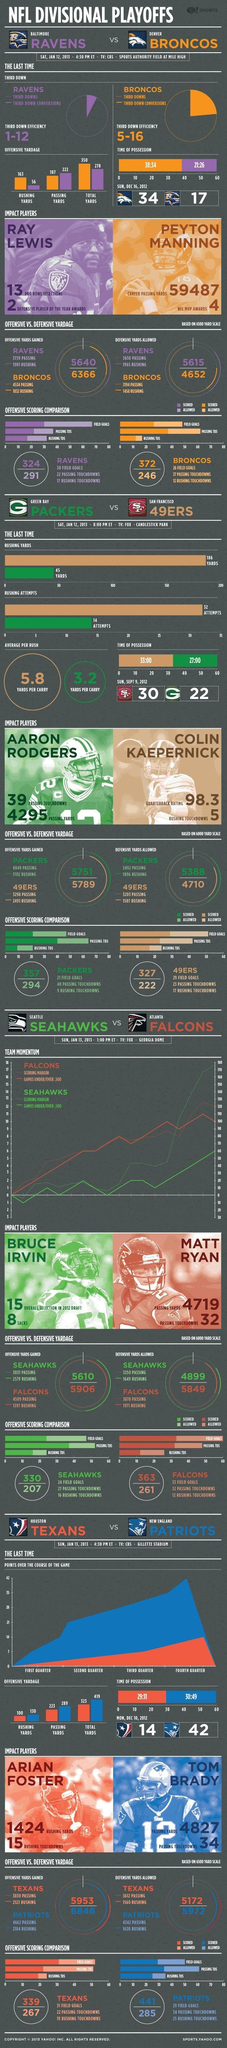What is the passing yards scored by Broncos?
Answer the question with a short phrase. 187 